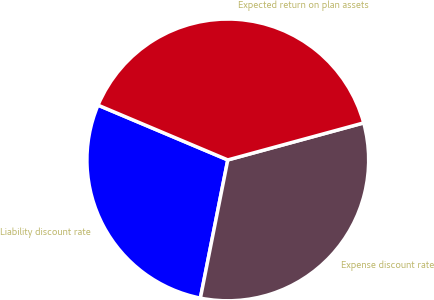Convert chart. <chart><loc_0><loc_0><loc_500><loc_500><pie_chart><fcel>Liability discount rate<fcel>Expense discount rate<fcel>Expected return on plan assets<nl><fcel>28.24%<fcel>32.35%<fcel>39.41%<nl></chart> 